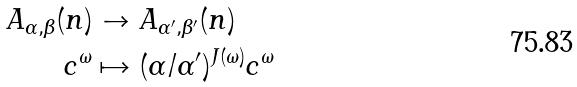Convert formula to latex. <formula><loc_0><loc_0><loc_500><loc_500>A _ { \alpha , \beta } ( n ) & \to A _ { \alpha ^ { \prime } , \beta ^ { \prime } } ( n ) \\ c ^ { \omega } & \mapsto ( \alpha / \alpha ^ { \prime } ) ^ { J ( \omega ) } c ^ { \omega }</formula> 